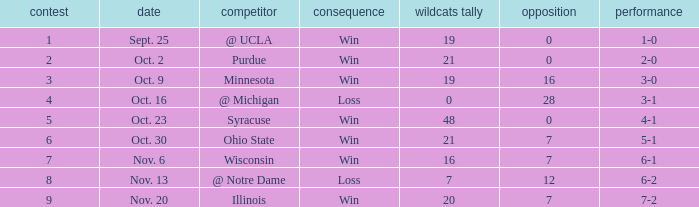What is the lowest points scored by the Wildcats when the record was 5-1? 21.0. 